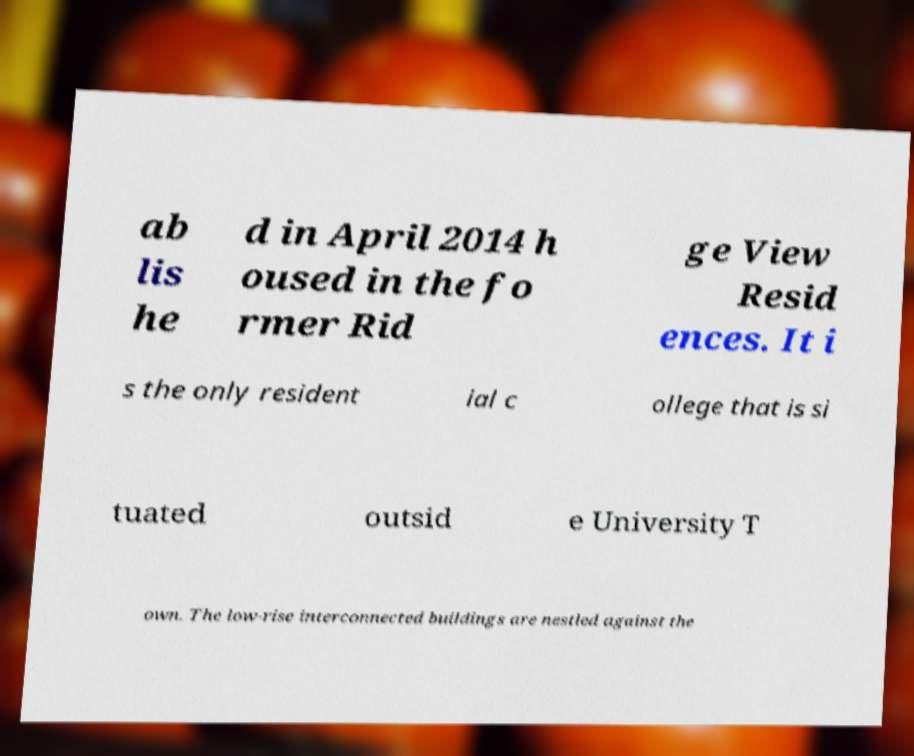I need the written content from this picture converted into text. Can you do that? ab lis he d in April 2014 h oused in the fo rmer Rid ge View Resid ences. It i s the only resident ial c ollege that is si tuated outsid e University T own. The low-rise interconnected buildings are nestled against the 